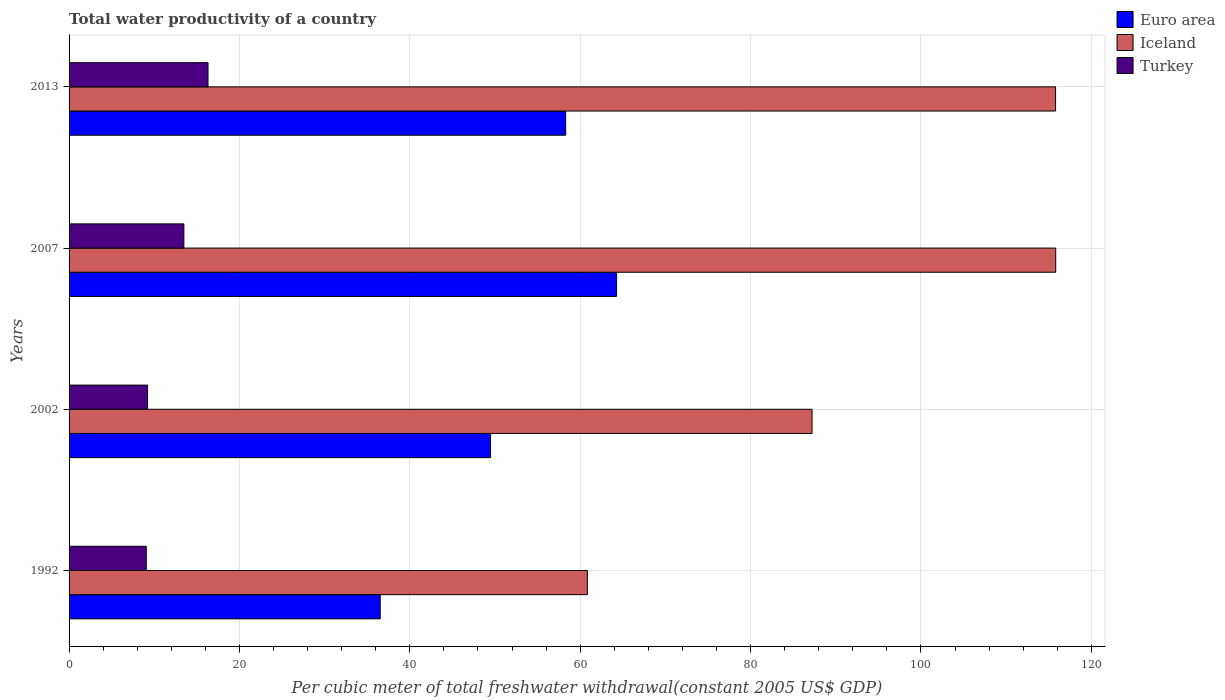How many different coloured bars are there?
Provide a succinct answer. 3. How many groups of bars are there?
Ensure brevity in your answer.  4. Are the number of bars on each tick of the Y-axis equal?
Offer a very short reply. Yes. How many bars are there on the 4th tick from the bottom?
Your response must be concise. 3. What is the label of the 4th group of bars from the top?
Offer a very short reply. 1992. In how many cases, is the number of bars for a given year not equal to the number of legend labels?
Keep it short and to the point. 0. What is the total water productivity in Iceland in 1992?
Keep it short and to the point. 60.84. Across all years, what is the maximum total water productivity in Iceland?
Your answer should be compact. 115.82. Across all years, what is the minimum total water productivity in Euro area?
Your response must be concise. 36.52. In which year was the total water productivity in Euro area maximum?
Your response must be concise. 2007. What is the total total water productivity in Iceland in the graph?
Offer a terse response. 379.69. What is the difference between the total water productivity in Euro area in 1992 and that in 2002?
Make the answer very short. -12.96. What is the difference between the total water productivity in Iceland in 2007 and the total water productivity in Turkey in 2002?
Give a very brief answer. 106.61. What is the average total water productivity in Iceland per year?
Your response must be concise. 94.92. In the year 2002, what is the difference between the total water productivity in Iceland and total water productivity in Euro area?
Provide a succinct answer. 37.74. In how many years, is the total water productivity in Iceland greater than 116 US$?
Ensure brevity in your answer.  0. What is the ratio of the total water productivity in Iceland in 2002 to that in 2013?
Provide a short and direct response. 0.75. Is the total water productivity in Euro area in 1992 less than that in 2002?
Your answer should be compact. Yes. What is the difference between the highest and the second highest total water productivity in Iceland?
Make the answer very short. 0.02. What is the difference between the highest and the lowest total water productivity in Iceland?
Your answer should be very brief. 54.98. Is it the case that in every year, the sum of the total water productivity in Turkey and total water productivity in Iceland is greater than the total water productivity in Euro area?
Offer a very short reply. Yes. How many bars are there?
Your response must be concise. 12. Are all the bars in the graph horizontal?
Give a very brief answer. Yes. How many years are there in the graph?
Your response must be concise. 4. What is the difference between two consecutive major ticks on the X-axis?
Ensure brevity in your answer.  20. Where does the legend appear in the graph?
Provide a succinct answer. Top right. How many legend labels are there?
Your response must be concise. 3. How are the legend labels stacked?
Your response must be concise. Vertical. What is the title of the graph?
Ensure brevity in your answer.  Total water productivity of a country. Does "Tanzania" appear as one of the legend labels in the graph?
Give a very brief answer. No. What is the label or title of the X-axis?
Your response must be concise. Per cubic meter of total freshwater withdrawal(constant 2005 US$ GDP). What is the label or title of the Y-axis?
Offer a terse response. Years. What is the Per cubic meter of total freshwater withdrawal(constant 2005 US$ GDP) in Euro area in 1992?
Provide a succinct answer. 36.52. What is the Per cubic meter of total freshwater withdrawal(constant 2005 US$ GDP) in Iceland in 1992?
Your answer should be very brief. 60.84. What is the Per cubic meter of total freshwater withdrawal(constant 2005 US$ GDP) of Turkey in 1992?
Provide a short and direct response. 9.06. What is the Per cubic meter of total freshwater withdrawal(constant 2005 US$ GDP) of Euro area in 2002?
Provide a short and direct response. 49.48. What is the Per cubic meter of total freshwater withdrawal(constant 2005 US$ GDP) in Iceland in 2002?
Provide a succinct answer. 87.22. What is the Per cubic meter of total freshwater withdrawal(constant 2005 US$ GDP) of Turkey in 2002?
Your answer should be very brief. 9.21. What is the Per cubic meter of total freshwater withdrawal(constant 2005 US$ GDP) in Euro area in 2007?
Offer a very short reply. 64.27. What is the Per cubic meter of total freshwater withdrawal(constant 2005 US$ GDP) in Iceland in 2007?
Keep it short and to the point. 115.82. What is the Per cubic meter of total freshwater withdrawal(constant 2005 US$ GDP) in Turkey in 2007?
Your response must be concise. 13.48. What is the Per cubic meter of total freshwater withdrawal(constant 2005 US$ GDP) of Euro area in 2013?
Ensure brevity in your answer.  58.3. What is the Per cubic meter of total freshwater withdrawal(constant 2005 US$ GDP) of Iceland in 2013?
Provide a short and direct response. 115.81. What is the Per cubic meter of total freshwater withdrawal(constant 2005 US$ GDP) in Turkey in 2013?
Your answer should be very brief. 16.31. Across all years, what is the maximum Per cubic meter of total freshwater withdrawal(constant 2005 US$ GDP) in Euro area?
Offer a very short reply. 64.27. Across all years, what is the maximum Per cubic meter of total freshwater withdrawal(constant 2005 US$ GDP) in Iceland?
Provide a short and direct response. 115.82. Across all years, what is the maximum Per cubic meter of total freshwater withdrawal(constant 2005 US$ GDP) of Turkey?
Ensure brevity in your answer.  16.31. Across all years, what is the minimum Per cubic meter of total freshwater withdrawal(constant 2005 US$ GDP) of Euro area?
Keep it short and to the point. 36.52. Across all years, what is the minimum Per cubic meter of total freshwater withdrawal(constant 2005 US$ GDP) in Iceland?
Offer a very short reply. 60.84. Across all years, what is the minimum Per cubic meter of total freshwater withdrawal(constant 2005 US$ GDP) of Turkey?
Keep it short and to the point. 9.06. What is the total Per cubic meter of total freshwater withdrawal(constant 2005 US$ GDP) in Euro area in the graph?
Offer a terse response. 208.57. What is the total Per cubic meter of total freshwater withdrawal(constant 2005 US$ GDP) of Iceland in the graph?
Keep it short and to the point. 379.69. What is the total Per cubic meter of total freshwater withdrawal(constant 2005 US$ GDP) of Turkey in the graph?
Offer a very short reply. 48.06. What is the difference between the Per cubic meter of total freshwater withdrawal(constant 2005 US$ GDP) in Euro area in 1992 and that in 2002?
Your answer should be compact. -12.96. What is the difference between the Per cubic meter of total freshwater withdrawal(constant 2005 US$ GDP) of Iceland in 1992 and that in 2002?
Your answer should be very brief. -26.38. What is the difference between the Per cubic meter of total freshwater withdrawal(constant 2005 US$ GDP) of Turkey in 1992 and that in 2002?
Ensure brevity in your answer.  -0.15. What is the difference between the Per cubic meter of total freshwater withdrawal(constant 2005 US$ GDP) of Euro area in 1992 and that in 2007?
Make the answer very short. -27.75. What is the difference between the Per cubic meter of total freshwater withdrawal(constant 2005 US$ GDP) in Iceland in 1992 and that in 2007?
Your answer should be compact. -54.98. What is the difference between the Per cubic meter of total freshwater withdrawal(constant 2005 US$ GDP) of Turkey in 1992 and that in 2007?
Your answer should be very brief. -4.41. What is the difference between the Per cubic meter of total freshwater withdrawal(constant 2005 US$ GDP) of Euro area in 1992 and that in 2013?
Your answer should be compact. -21.77. What is the difference between the Per cubic meter of total freshwater withdrawal(constant 2005 US$ GDP) in Iceland in 1992 and that in 2013?
Your answer should be very brief. -54.97. What is the difference between the Per cubic meter of total freshwater withdrawal(constant 2005 US$ GDP) in Turkey in 1992 and that in 2013?
Give a very brief answer. -7.25. What is the difference between the Per cubic meter of total freshwater withdrawal(constant 2005 US$ GDP) of Euro area in 2002 and that in 2007?
Your response must be concise. -14.79. What is the difference between the Per cubic meter of total freshwater withdrawal(constant 2005 US$ GDP) of Iceland in 2002 and that in 2007?
Your answer should be very brief. -28.6. What is the difference between the Per cubic meter of total freshwater withdrawal(constant 2005 US$ GDP) of Turkey in 2002 and that in 2007?
Offer a terse response. -4.26. What is the difference between the Per cubic meter of total freshwater withdrawal(constant 2005 US$ GDP) in Euro area in 2002 and that in 2013?
Make the answer very short. -8.82. What is the difference between the Per cubic meter of total freshwater withdrawal(constant 2005 US$ GDP) in Iceland in 2002 and that in 2013?
Offer a terse response. -28.59. What is the difference between the Per cubic meter of total freshwater withdrawal(constant 2005 US$ GDP) in Turkey in 2002 and that in 2013?
Provide a succinct answer. -7.1. What is the difference between the Per cubic meter of total freshwater withdrawal(constant 2005 US$ GDP) in Euro area in 2007 and that in 2013?
Provide a short and direct response. 5.98. What is the difference between the Per cubic meter of total freshwater withdrawal(constant 2005 US$ GDP) in Iceland in 2007 and that in 2013?
Your answer should be compact. 0.02. What is the difference between the Per cubic meter of total freshwater withdrawal(constant 2005 US$ GDP) of Turkey in 2007 and that in 2013?
Make the answer very short. -2.83. What is the difference between the Per cubic meter of total freshwater withdrawal(constant 2005 US$ GDP) of Euro area in 1992 and the Per cubic meter of total freshwater withdrawal(constant 2005 US$ GDP) of Iceland in 2002?
Make the answer very short. -50.7. What is the difference between the Per cubic meter of total freshwater withdrawal(constant 2005 US$ GDP) in Euro area in 1992 and the Per cubic meter of total freshwater withdrawal(constant 2005 US$ GDP) in Turkey in 2002?
Your answer should be very brief. 27.31. What is the difference between the Per cubic meter of total freshwater withdrawal(constant 2005 US$ GDP) in Iceland in 1992 and the Per cubic meter of total freshwater withdrawal(constant 2005 US$ GDP) in Turkey in 2002?
Provide a succinct answer. 51.62. What is the difference between the Per cubic meter of total freshwater withdrawal(constant 2005 US$ GDP) of Euro area in 1992 and the Per cubic meter of total freshwater withdrawal(constant 2005 US$ GDP) of Iceland in 2007?
Keep it short and to the point. -79.3. What is the difference between the Per cubic meter of total freshwater withdrawal(constant 2005 US$ GDP) in Euro area in 1992 and the Per cubic meter of total freshwater withdrawal(constant 2005 US$ GDP) in Turkey in 2007?
Give a very brief answer. 23.05. What is the difference between the Per cubic meter of total freshwater withdrawal(constant 2005 US$ GDP) of Iceland in 1992 and the Per cubic meter of total freshwater withdrawal(constant 2005 US$ GDP) of Turkey in 2007?
Your response must be concise. 47.36. What is the difference between the Per cubic meter of total freshwater withdrawal(constant 2005 US$ GDP) of Euro area in 1992 and the Per cubic meter of total freshwater withdrawal(constant 2005 US$ GDP) of Iceland in 2013?
Your answer should be compact. -79.28. What is the difference between the Per cubic meter of total freshwater withdrawal(constant 2005 US$ GDP) in Euro area in 1992 and the Per cubic meter of total freshwater withdrawal(constant 2005 US$ GDP) in Turkey in 2013?
Give a very brief answer. 20.21. What is the difference between the Per cubic meter of total freshwater withdrawal(constant 2005 US$ GDP) in Iceland in 1992 and the Per cubic meter of total freshwater withdrawal(constant 2005 US$ GDP) in Turkey in 2013?
Ensure brevity in your answer.  44.53. What is the difference between the Per cubic meter of total freshwater withdrawal(constant 2005 US$ GDP) of Euro area in 2002 and the Per cubic meter of total freshwater withdrawal(constant 2005 US$ GDP) of Iceland in 2007?
Offer a very short reply. -66.34. What is the difference between the Per cubic meter of total freshwater withdrawal(constant 2005 US$ GDP) of Euro area in 2002 and the Per cubic meter of total freshwater withdrawal(constant 2005 US$ GDP) of Turkey in 2007?
Your answer should be very brief. 36. What is the difference between the Per cubic meter of total freshwater withdrawal(constant 2005 US$ GDP) in Iceland in 2002 and the Per cubic meter of total freshwater withdrawal(constant 2005 US$ GDP) in Turkey in 2007?
Ensure brevity in your answer.  73.74. What is the difference between the Per cubic meter of total freshwater withdrawal(constant 2005 US$ GDP) in Euro area in 2002 and the Per cubic meter of total freshwater withdrawal(constant 2005 US$ GDP) in Iceland in 2013?
Keep it short and to the point. -66.33. What is the difference between the Per cubic meter of total freshwater withdrawal(constant 2005 US$ GDP) in Euro area in 2002 and the Per cubic meter of total freshwater withdrawal(constant 2005 US$ GDP) in Turkey in 2013?
Provide a succinct answer. 33.17. What is the difference between the Per cubic meter of total freshwater withdrawal(constant 2005 US$ GDP) of Iceland in 2002 and the Per cubic meter of total freshwater withdrawal(constant 2005 US$ GDP) of Turkey in 2013?
Your answer should be compact. 70.91. What is the difference between the Per cubic meter of total freshwater withdrawal(constant 2005 US$ GDP) in Euro area in 2007 and the Per cubic meter of total freshwater withdrawal(constant 2005 US$ GDP) in Iceland in 2013?
Give a very brief answer. -51.53. What is the difference between the Per cubic meter of total freshwater withdrawal(constant 2005 US$ GDP) in Euro area in 2007 and the Per cubic meter of total freshwater withdrawal(constant 2005 US$ GDP) in Turkey in 2013?
Your answer should be very brief. 47.96. What is the difference between the Per cubic meter of total freshwater withdrawal(constant 2005 US$ GDP) of Iceland in 2007 and the Per cubic meter of total freshwater withdrawal(constant 2005 US$ GDP) of Turkey in 2013?
Provide a succinct answer. 99.51. What is the average Per cubic meter of total freshwater withdrawal(constant 2005 US$ GDP) in Euro area per year?
Give a very brief answer. 52.14. What is the average Per cubic meter of total freshwater withdrawal(constant 2005 US$ GDP) in Iceland per year?
Your answer should be compact. 94.92. What is the average Per cubic meter of total freshwater withdrawal(constant 2005 US$ GDP) in Turkey per year?
Make the answer very short. 12.02. In the year 1992, what is the difference between the Per cubic meter of total freshwater withdrawal(constant 2005 US$ GDP) of Euro area and Per cubic meter of total freshwater withdrawal(constant 2005 US$ GDP) of Iceland?
Your answer should be very brief. -24.32. In the year 1992, what is the difference between the Per cubic meter of total freshwater withdrawal(constant 2005 US$ GDP) of Euro area and Per cubic meter of total freshwater withdrawal(constant 2005 US$ GDP) of Turkey?
Your answer should be compact. 27.46. In the year 1992, what is the difference between the Per cubic meter of total freshwater withdrawal(constant 2005 US$ GDP) of Iceland and Per cubic meter of total freshwater withdrawal(constant 2005 US$ GDP) of Turkey?
Your response must be concise. 51.78. In the year 2002, what is the difference between the Per cubic meter of total freshwater withdrawal(constant 2005 US$ GDP) in Euro area and Per cubic meter of total freshwater withdrawal(constant 2005 US$ GDP) in Iceland?
Your answer should be very brief. -37.74. In the year 2002, what is the difference between the Per cubic meter of total freshwater withdrawal(constant 2005 US$ GDP) in Euro area and Per cubic meter of total freshwater withdrawal(constant 2005 US$ GDP) in Turkey?
Offer a very short reply. 40.27. In the year 2002, what is the difference between the Per cubic meter of total freshwater withdrawal(constant 2005 US$ GDP) in Iceland and Per cubic meter of total freshwater withdrawal(constant 2005 US$ GDP) in Turkey?
Give a very brief answer. 78. In the year 2007, what is the difference between the Per cubic meter of total freshwater withdrawal(constant 2005 US$ GDP) in Euro area and Per cubic meter of total freshwater withdrawal(constant 2005 US$ GDP) in Iceland?
Your answer should be compact. -51.55. In the year 2007, what is the difference between the Per cubic meter of total freshwater withdrawal(constant 2005 US$ GDP) in Euro area and Per cubic meter of total freshwater withdrawal(constant 2005 US$ GDP) in Turkey?
Ensure brevity in your answer.  50.8. In the year 2007, what is the difference between the Per cubic meter of total freshwater withdrawal(constant 2005 US$ GDP) of Iceland and Per cubic meter of total freshwater withdrawal(constant 2005 US$ GDP) of Turkey?
Offer a very short reply. 102.35. In the year 2013, what is the difference between the Per cubic meter of total freshwater withdrawal(constant 2005 US$ GDP) in Euro area and Per cubic meter of total freshwater withdrawal(constant 2005 US$ GDP) in Iceland?
Offer a very short reply. -57.51. In the year 2013, what is the difference between the Per cubic meter of total freshwater withdrawal(constant 2005 US$ GDP) in Euro area and Per cubic meter of total freshwater withdrawal(constant 2005 US$ GDP) in Turkey?
Keep it short and to the point. 41.98. In the year 2013, what is the difference between the Per cubic meter of total freshwater withdrawal(constant 2005 US$ GDP) of Iceland and Per cubic meter of total freshwater withdrawal(constant 2005 US$ GDP) of Turkey?
Your answer should be compact. 99.5. What is the ratio of the Per cubic meter of total freshwater withdrawal(constant 2005 US$ GDP) in Euro area in 1992 to that in 2002?
Provide a succinct answer. 0.74. What is the ratio of the Per cubic meter of total freshwater withdrawal(constant 2005 US$ GDP) in Iceland in 1992 to that in 2002?
Your answer should be compact. 0.7. What is the ratio of the Per cubic meter of total freshwater withdrawal(constant 2005 US$ GDP) of Turkey in 1992 to that in 2002?
Offer a terse response. 0.98. What is the ratio of the Per cubic meter of total freshwater withdrawal(constant 2005 US$ GDP) of Euro area in 1992 to that in 2007?
Offer a very short reply. 0.57. What is the ratio of the Per cubic meter of total freshwater withdrawal(constant 2005 US$ GDP) of Iceland in 1992 to that in 2007?
Offer a terse response. 0.53. What is the ratio of the Per cubic meter of total freshwater withdrawal(constant 2005 US$ GDP) in Turkey in 1992 to that in 2007?
Give a very brief answer. 0.67. What is the ratio of the Per cubic meter of total freshwater withdrawal(constant 2005 US$ GDP) of Euro area in 1992 to that in 2013?
Provide a succinct answer. 0.63. What is the ratio of the Per cubic meter of total freshwater withdrawal(constant 2005 US$ GDP) of Iceland in 1992 to that in 2013?
Provide a succinct answer. 0.53. What is the ratio of the Per cubic meter of total freshwater withdrawal(constant 2005 US$ GDP) in Turkey in 1992 to that in 2013?
Make the answer very short. 0.56. What is the ratio of the Per cubic meter of total freshwater withdrawal(constant 2005 US$ GDP) in Euro area in 2002 to that in 2007?
Your answer should be very brief. 0.77. What is the ratio of the Per cubic meter of total freshwater withdrawal(constant 2005 US$ GDP) of Iceland in 2002 to that in 2007?
Offer a very short reply. 0.75. What is the ratio of the Per cubic meter of total freshwater withdrawal(constant 2005 US$ GDP) in Turkey in 2002 to that in 2007?
Give a very brief answer. 0.68. What is the ratio of the Per cubic meter of total freshwater withdrawal(constant 2005 US$ GDP) in Euro area in 2002 to that in 2013?
Ensure brevity in your answer.  0.85. What is the ratio of the Per cubic meter of total freshwater withdrawal(constant 2005 US$ GDP) of Iceland in 2002 to that in 2013?
Your answer should be compact. 0.75. What is the ratio of the Per cubic meter of total freshwater withdrawal(constant 2005 US$ GDP) in Turkey in 2002 to that in 2013?
Your response must be concise. 0.56. What is the ratio of the Per cubic meter of total freshwater withdrawal(constant 2005 US$ GDP) in Euro area in 2007 to that in 2013?
Your response must be concise. 1.1. What is the ratio of the Per cubic meter of total freshwater withdrawal(constant 2005 US$ GDP) in Iceland in 2007 to that in 2013?
Offer a terse response. 1. What is the ratio of the Per cubic meter of total freshwater withdrawal(constant 2005 US$ GDP) of Turkey in 2007 to that in 2013?
Give a very brief answer. 0.83. What is the difference between the highest and the second highest Per cubic meter of total freshwater withdrawal(constant 2005 US$ GDP) in Euro area?
Ensure brevity in your answer.  5.98. What is the difference between the highest and the second highest Per cubic meter of total freshwater withdrawal(constant 2005 US$ GDP) in Iceland?
Your response must be concise. 0.02. What is the difference between the highest and the second highest Per cubic meter of total freshwater withdrawal(constant 2005 US$ GDP) in Turkey?
Provide a succinct answer. 2.83. What is the difference between the highest and the lowest Per cubic meter of total freshwater withdrawal(constant 2005 US$ GDP) of Euro area?
Offer a very short reply. 27.75. What is the difference between the highest and the lowest Per cubic meter of total freshwater withdrawal(constant 2005 US$ GDP) of Iceland?
Make the answer very short. 54.98. What is the difference between the highest and the lowest Per cubic meter of total freshwater withdrawal(constant 2005 US$ GDP) of Turkey?
Provide a succinct answer. 7.25. 